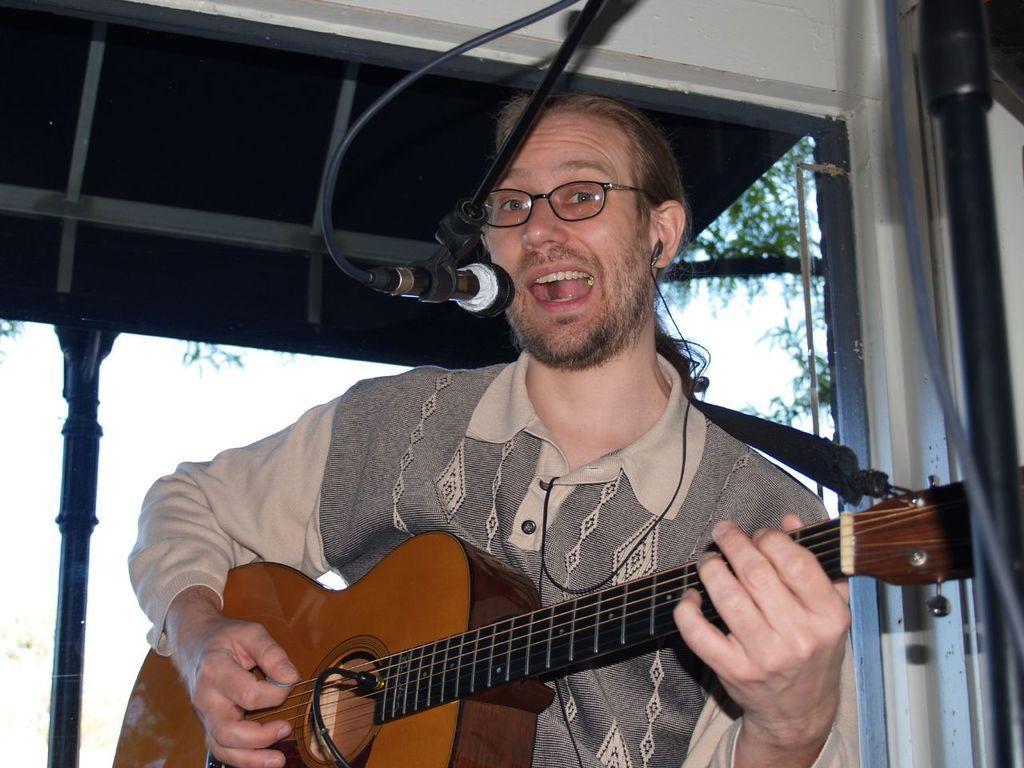Please provide a concise description of this image. In this picture there is a man playing a guitar and he is singing, before him there is a mike. In the background there is shed, pole and a tree. 